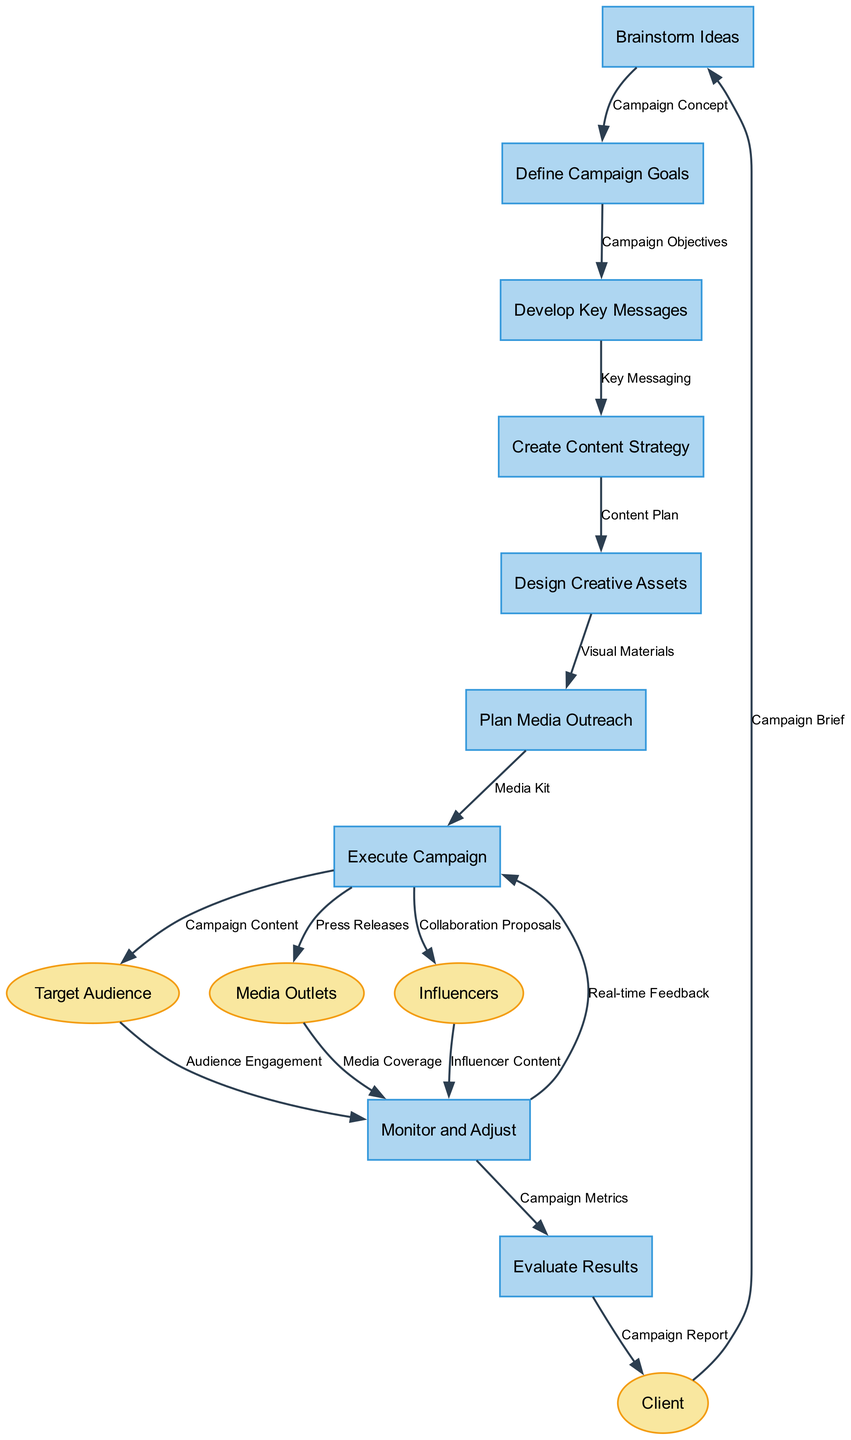What is the first process in the diagram? The first process in the diagram is labeled as "Brainstorm Ideas." This is the starting point before any campaign goals are defined.
Answer: Brainstorm Ideas How many external entities are shown in the diagram? The diagram features a total of four external entities, which are the Client, Target Audience, Media Outlets, and Influencers. This count represents all the different external stakeholders involved in the campaign workflow.
Answer: 4 What data flows from the Execute Campaign process to the Target Audience? The data flowing from the Execute Campaign process to the Target Audience is labeled as "Campaign Content." This indicates what is shared with the audience during the execution stage.
Answer: Campaign Content Which process follows the "Define Campaign Goals" process? The process that follows "Define Campaign Goals" is "Develop Key Messages." This connection shows the sequential progression from setting goals to crafting the messages that will be communicated.
Answer: Develop Key Messages What type of feedback is provided to the Execute Campaign process during "Monitor and Adjust"? The type of feedback provided to the Execute Campaign process is "Real-time Feedback." This feedback is important for making on-the-fly changes during the campaign execution based on current performance.
Answer: Real-time Feedback How many total data flows are present in the diagram? The total number of data flows in the diagram is fifteen. This includes all the connections showing the flow of information between processes and external entities throughout the campaign workflow.
Answer: 15 What is the final output sent to the Client from the Evaluate Results process? The final output sent to the Client from the Evaluate Results process is termed as "Campaign Report." This report summarizes the outcome and effectiveness of the campaign after evaluation.
Answer: Campaign Report Which process directly results from the "Create Content Strategy"? The process that directly results from the "Create Content Strategy" is "Design Creative Assets." This relationship emphasizes the progression from planning content to producing the visual elements needed for the campaign.
Answer: Design Creative Assets What are the sources of data that feed back into "Monitor and Adjust"? The sources of data feeding back into "Monitor and Adjust" include Audience Engagement from the Target Audience, Media Coverage from Media Outlets, and Influencer Content from Influencers. These inputs help assess the campaign's reach and effectiveness.
Answer: Audience Engagement, Media Coverage, Influencer Content 